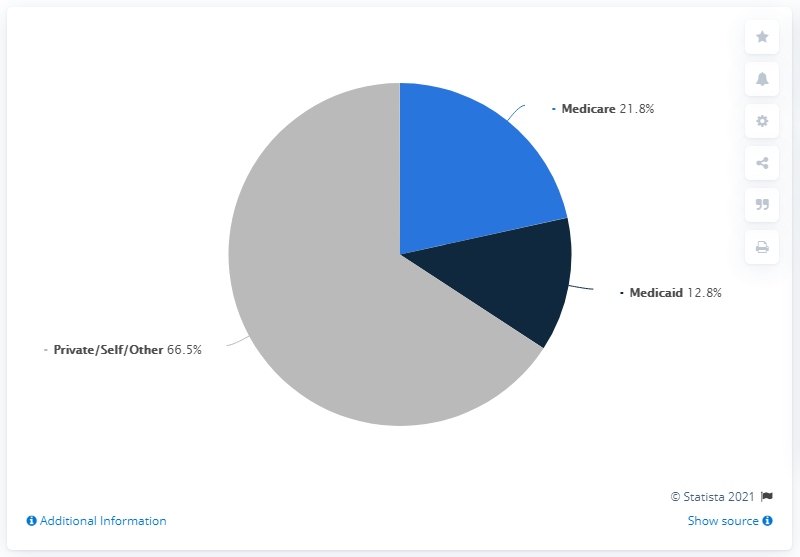Mention a couple of crucial points in this snapshot. Medicare is a government-funded health insurance program in the United States that is predominantly blue in color. It is often referred to as "light blue" for its slightly lighter shade compared to other blue colors. In 2020, private and self-payments accounted for approximately 66.5% of the hospital revenue. The total of Medicaid and private spending on inpatient care for individuals with serious mental illness was 79.3%. 